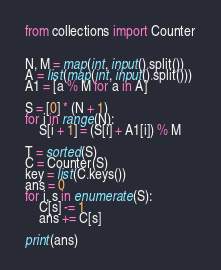Convert code to text. <code><loc_0><loc_0><loc_500><loc_500><_Python_>from collections import Counter


N, M = map(int, input().split())
A = list(map(int, input().split()))
A1 = [a % M for a in A]

S = [0] * (N + 1)
for i in range(N):
    S[i + 1] = (S[i] + A1[i]) % M

T = sorted(S)
C = Counter(S)
key = list(C.keys())
ans = 0
for i, s in enumerate(S):
    C[s] -= 1
    ans += C[s]

print(ans)
</code> 